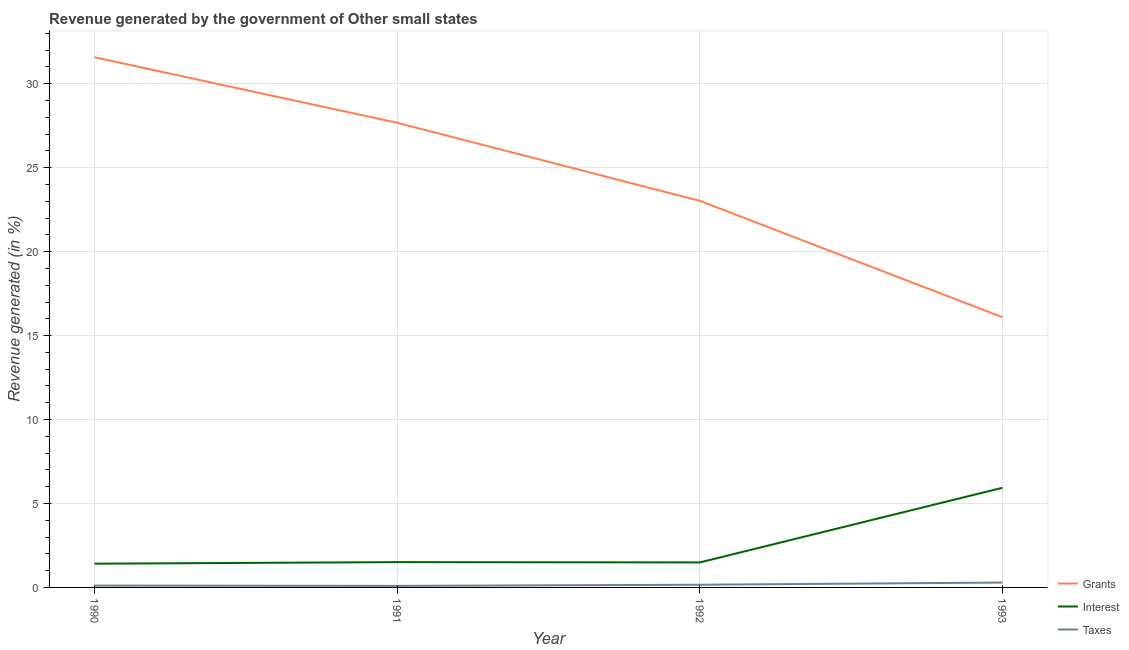What is the percentage of revenue generated by taxes in 1993?
Your answer should be compact. 0.29. Across all years, what is the maximum percentage of revenue generated by taxes?
Offer a very short reply. 0.29. Across all years, what is the minimum percentage of revenue generated by taxes?
Make the answer very short. 0.09. In which year was the percentage of revenue generated by interest minimum?
Offer a very short reply. 1990. What is the total percentage of revenue generated by grants in the graph?
Your response must be concise. 98.37. What is the difference between the percentage of revenue generated by interest in 1991 and that in 1993?
Provide a short and direct response. -4.43. What is the difference between the percentage of revenue generated by grants in 1992 and the percentage of revenue generated by taxes in 1991?
Your answer should be very brief. 22.93. What is the average percentage of revenue generated by interest per year?
Give a very brief answer. 2.59. In the year 1990, what is the difference between the percentage of revenue generated by interest and percentage of revenue generated by taxes?
Provide a short and direct response. 1.3. In how many years, is the percentage of revenue generated by taxes greater than 32 %?
Ensure brevity in your answer.  0. What is the ratio of the percentage of revenue generated by taxes in 1991 to that in 1992?
Give a very brief answer. 0.57. Is the difference between the percentage of revenue generated by interest in 1991 and 1992 greater than the difference between the percentage of revenue generated by taxes in 1991 and 1992?
Provide a succinct answer. Yes. What is the difference between the highest and the second highest percentage of revenue generated by grants?
Make the answer very short. 3.9. What is the difference between the highest and the lowest percentage of revenue generated by grants?
Your answer should be compact. 15.48. In how many years, is the percentage of revenue generated by grants greater than the average percentage of revenue generated by grants taken over all years?
Make the answer very short. 2. Is the sum of the percentage of revenue generated by grants in 1990 and 1992 greater than the maximum percentage of revenue generated by taxes across all years?
Make the answer very short. Yes. How many years are there in the graph?
Offer a very short reply. 4. Are the values on the major ticks of Y-axis written in scientific E-notation?
Your answer should be very brief. No. Does the graph contain any zero values?
Offer a very short reply. No. What is the title of the graph?
Provide a succinct answer. Revenue generated by the government of Other small states. Does "Social Protection and Labor" appear as one of the legend labels in the graph?
Offer a terse response. No. What is the label or title of the X-axis?
Ensure brevity in your answer.  Year. What is the label or title of the Y-axis?
Your response must be concise. Revenue generated (in %). What is the Revenue generated (in %) of Grants in 1990?
Offer a very short reply. 31.58. What is the Revenue generated (in %) of Interest in 1990?
Keep it short and to the point. 1.41. What is the Revenue generated (in %) in Taxes in 1990?
Offer a terse response. 0.11. What is the Revenue generated (in %) in Grants in 1991?
Your answer should be very brief. 27.68. What is the Revenue generated (in %) of Interest in 1991?
Your answer should be compact. 1.51. What is the Revenue generated (in %) in Taxes in 1991?
Give a very brief answer. 0.09. What is the Revenue generated (in %) of Grants in 1992?
Make the answer very short. 23.02. What is the Revenue generated (in %) of Interest in 1992?
Your answer should be compact. 1.49. What is the Revenue generated (in %) of Taxes in 1992?
Provide a short and direct response. 0.16. What is the Revenue generated (in %) of Grants in 1993?
Your answer should be very brief. 16.09. What is the Revenue generated (in %) of Interest in 1993?
Offer a terse response. 5.93. What is the Revenue generated (in %) of Taxes in 1993?
Your answer should be very brief. 0.29. Across all years, what is the maximum Revenue generated (in %) of Grants?
Make the answer very short. 31.58. Across all years, what is the maximum Revenue generated (in %) in Interest?
Ensure brevity in your answer.  5.93. Across all years, what is the maximum Revenue generated (in %) in Taxes?
Provide a short and direct response. 0.29. Across all years, what is the minimum Revenue generated (in %) of Grants?
Make the answer very short. 16.09. Across all years, what is the minimum Revenue generated (in %) in Interest?
Offer a very short reply. 1.41. Across all years, what is the minimum Revenue generated (in %) in Taxes?
Ensure brevity in your answer.  0.09. What is the total Revenue generated (in %) of Grants in the graph?
Your answer should be compact. 98.37. What is the total Revenue generated (in %) of Interest in the graph?
Your answer should be very brief. 10.35. What is the total Revenue generated (in %) in Taxes in the graph?
Keep it short and to the point. 0.65. What is the difference between the Revenue generated (in %) in Grants in 1990 and that in 1991?
Provide a succinct answer. 3.9. What is the difference between the Revenue generated (in %) of Interest in 1990 and that in 1991?
Offer a terse response. -0.09. What is the difference between the Revenue generated (in %) of Taxes in 1990 and that in 1991?
Ensure brevity in your answer.  0.02. What is the difference between the Revenue generated (in %) of Grants in 1990 and that in 1992?
Keep it short and to the point. 8.55. What is the difference between the Revenue generated (in %) in Interest in 1990 and that in 1992?
Offer a terse response. -0.07. What is the difference between the Revenue generated (in %) of Taxes in 1990 and that in 1992?
Offer a terse response. -0.05. What is the difference between the Revenue generated (in %) in Grants in 1990 and that in 1993?
Ensure brevity in your answer.  15.48. What is the difference between the Revenue generated (in %) of Interest in 1990 and that in 1993?
Ensure brevity in your answer.  -4.52. What is the difference between the Revenue generated (in %) of Taxes in 1990 and that in 1993?
Provide a succinct answer. -0.18. What is the difference between the Revenue generated (in %) of Grants in 1991 and that in 1992?
Ensure brevity in your answer.  4.65. What is the difference between the Revenue generated (in %) of Interest in 1991 and that in 1992?
Give a very brief answer. 0.02. What is the difference between the Revenue generated (in %) of Taxes in 1991 and that in 1992?
Keep it short and to the point. -0.07. What is the difference between the Revenue generated (in %) of Grants in 1991 and that in 1993?
Ensure brevity in your answer.  11.58. What is the difference between the Revenue generated (in %) of Interest in 1991 and that in 1993?
Your answer should be compact. -4.43. What is the difference between the Revenue generated (in %) in Taxes in 1991 and that in 1993?
Ensure brevity in your answer.  -0.2. What is the difference between the Revenue generated (in %) in Grants in 1992 and that in 1993?
Provide a succinct answer. 6.93. What is the difference between the Revenue generated (in %) of Interest in 1992 and that in 1993?
Ensure brevity in your answer.  -4.45. What is the difference between the Revenue generated (in %) in Taxes in 1992 and that in 1993?
Ensure brevity in your answer.  -0.13. What is the difference between the Revenue generated (in %) of Grants in 1990 and the Revenue generated (in %) of Interest in 1991?
Offer a terse response. 30.07. What is the difference between the Revenue generated (in %) in Grants in 1990 and the Revenue generated (in %) in Taxes in 1991?
Make the answer very short. 31.49. What is the difference between the Revenue generated (in %) of Interest in 1990 and the Revenue generated (in %) of Taxes in 1991?
Your response must be concise. 1.32. What is the difference between the Revenue generated (in %) of Grants in 1990 and the Revenue generated (in %) of Interest in 1992?
Provide a succinct answer. 30.09. What is the difference between the Revenue generated (in %) in Grants in 1990 and the Revenue generated (in %) in Taxes in 1992?
Offer a very short reply. 31.42. What is the difference between the Revenue generated (in %) in Interest in 1990 and the Revenue generated (in %) in Taxes in 1992?
Make the answer very short. 1.25. What is the difference between the Revenue generated (in %) in Grants in 1990 and the Revenue generated (in %) in Interest in 1993?
Offer a terse response. 25.64. What is the difference between the Revenue generated (in %) in Grants in 1990 and the Revenue generated (in %) in Taxes in 1993?
Ensure brevity in your answer.  31.29. What is the difference between the Revenue generated (in %) of Interest in 1990 and the Revenue generated (in %) of Taxes in 1993?
Offer a terse response. 1.12. What is the difference between the Revenue generated (in %) of Grants in 1991 and the Revenue generated (in %) of Interest in 1992?
Provide a succinct answer. 26.19. What is the difference between the Revenue generated (in %) in Grants in 1991 and the Revenue generated (in %) in Taxes in 1992?
Give a very brief answer. 27.51. What is the difference between the Revenue generated (in %) in Interest in 1991 and the Revenue generated (in %) in Taxes in 1992?
Offer a terse response. 1.35. What is the difference between the Revenue generated (in %) of Grants in 1991 and the Revenue generated (in %) of Interest in 1993?
Keep it short and to the point. 21.74. What is the difference between the Revenue generated (in %) of Grants in 1991 and the Revenue generated (in %) of Taxes in 1993?
Offer a very short reply. 27.38. What is the difference between the Revenue generated (in %) in Interest in 1991 and the Revenue generated (in %) in Taxes in 1993?
Ensure brevity in your answer.  1.22. What is the difference between the Revenue generated (in %) in Grants in 1992 and the Revenue generated (in %) in Interest in 1993?
Ensure brevity in your answer.  17.09. What is the difference between the Revenue generated (in %) of Grants in 1992 and the Revenue generated (in %) of Taxes in 1993?
Your answer should be compact. 22.73. What is the difference between the Revenue generated (in %) of Interest in 1992 and the Revenue generated (in %) of Taxes in 1993?
Your response must be concise. 1.2. What is the average Revenue generated (in %) in Grants per year?
Provide a succinct answer. 24.59. What is the average Revenue generated (in %) of Interest per year?
Give a very brief answer. 2.59. What is the average Revenue generated (in %) of Taxes per year?
Your answer should be compact. 0.16. In the year 1990, what is the difference between the Revenue generated (in %) in Grants and Revenue generated (in %) in Interest?
Your response must be concise. 30.16. In the year 1990, what is the difference between the Revenue generated (in %) of Grants and Revenue generated (in %) of Taxes?
Give a very brief answer. 31.47. In the year 1990, what is the difference between the Revenue generated (in %) of Interest and Revenue generated (in %) of Taxes?
Ensure brevity in your answer.  1.3. In the year 1991, what is the difference between the Revenue generated (in %) in Grants and Revenue generated (in %) in Interest?
Ensure brevity in your answer.  26.17. In the year 1991, what is the difference between the Revenue generated (in %) of Grants and Revenue generated (in %) of Taxes?
Provide a short and direct response. 27.58. In the year 1991, what is the difference between the Revenue generated (in %) of Interest and Revenue generated (in %) of Taxes?
Give a very brief answer. 1.42. In the year 1992, what is the difference between the Revenue generated (in %) of Grants and Revenue generated (in %) of Interest?
Make the answer very short. 21.54. In the year 1992, what is the difference between the Revenue generated (in %) of Grants and Revenue generated (in %) of Taxes?
Offer a terse response. 22.86. In the year 1992, what is the difference between the Revenue generated (in %) in Interest and Revenue generated (in %) in Taxes?
Keep it short and to the point. 1.33. In the year 1993, what is the difference between the Revenue generated (in %) in Grants and Revenue generated (in %) in Interest?
Provide a short and direct response. 10.16. In the year 1993, what is the difference between the Revenue generated (in %) in Grants and Revenue generated (in %) in Taxes?
Offer a very short reply. 15.8. In the year 1993, what is the difference between the Revenue generated (in %) in Interest and Revenue generated (in %) in Taxes?
Offer a terse response. 5.64. What is the ratio of the Revenue generated (in %) in Grants in 1990 to that in 1991?
Provide a short and direct response. 1.14. What is the ratio of the Revenue generated (in %) in Interest in 1990 to that in 1991?
Give a very brief answer. 0.94. What is the ratio of the Revenue generated (in %) of Taxes in 1990 to that in 1991?
Provide a succinct answer. 1.21. What is the ratio of the Revenue generated (in %) of Grants in 1990 to that in 1992?
Ensure brevity in your answer.  1.37. What is the ratio of the Revenue generated (in %) in Interest in 1990 to that in 1992?
Your response must be concise. 0.95. What is the ratio of the Revenue generated (in %) of Taxes in 1990 to that in 1992?
Ensure brevity in your answer.  0.69. What is the ratio of the Revenue generated (in %) in Grants in 1990 to that in 1993?
Your answer should be compact. 1.96. What is the ratio of the Revenue generated (in %) of Interest in 1990 to that in 1993?
Ensure brevity in your answer.  0.24. What is the ratio of the Revenue generated (in %) of Taxes in 1990 to that in 1993?
Provide a succinct answer. 0.38. What is the ratio of the Revenue generated (in %) of Grants in 1991 to that in 1992?
Keep it short and to the point. 1.2. What is the ratio of the Revenue generated (in %) of Interest in 1991 to that in 1992?
Provide a short and direct response. 1.01. What is the ratio of the Revenue generated (in %) in Taxes in 1991 to that in 1992?
Keep it short and to the point. 0.57. What is the ratio of the Revenue generated (in %) in Grants in 1991 to that in 1993?
Provide a short and direct response. 1.72. What is the ratio of the Revenue generated (in %) of Interest in 1991 to that in 1993?
Keep it short and to the point. 0.25. What is the ratio of the Revenue generated (in %) of Taxes in 1991 to that in 1993?
Your response must be concise. 0.31. What is the ratio of the Revenue generated (in %) of Grants in 1992 to that in 1993?
Ensure brevity in your answer.  1.43. What is the ratio of the Revenue generated (in %) of Interest in 1992 to that in 1993?
Offer a very short reply. 0.25. What is the ratio of the Revenue generated (in %) of Taxes in 1992 to that in 1993?
Provide a short and direct response. 0.55. What is the difference between the highest and the second highest Revenue generated (in %) of Grants?
Ensure brevity in your answer.  3.9. What is the difference between the highest and the second highest Revenue generated (in %) of Interest?
Your answer should be very brief. 4.43. What is the difference between the highest and the second highest Revenue generated (in %) in Taxes?
Your response must be concise. 0.13. What is the difference between the highest and the lowest Revenue generated (in %) in Grants?
Offer a terse response. 15.48. What is the difference between the highest and the lowest Revenue generated (in %) of Interest?
Give a very brief answer. 4.52. What is the difference between the highest and the lowest Revenue generated (in %) of Taxes?
Give a very brief answer. 0.2. 